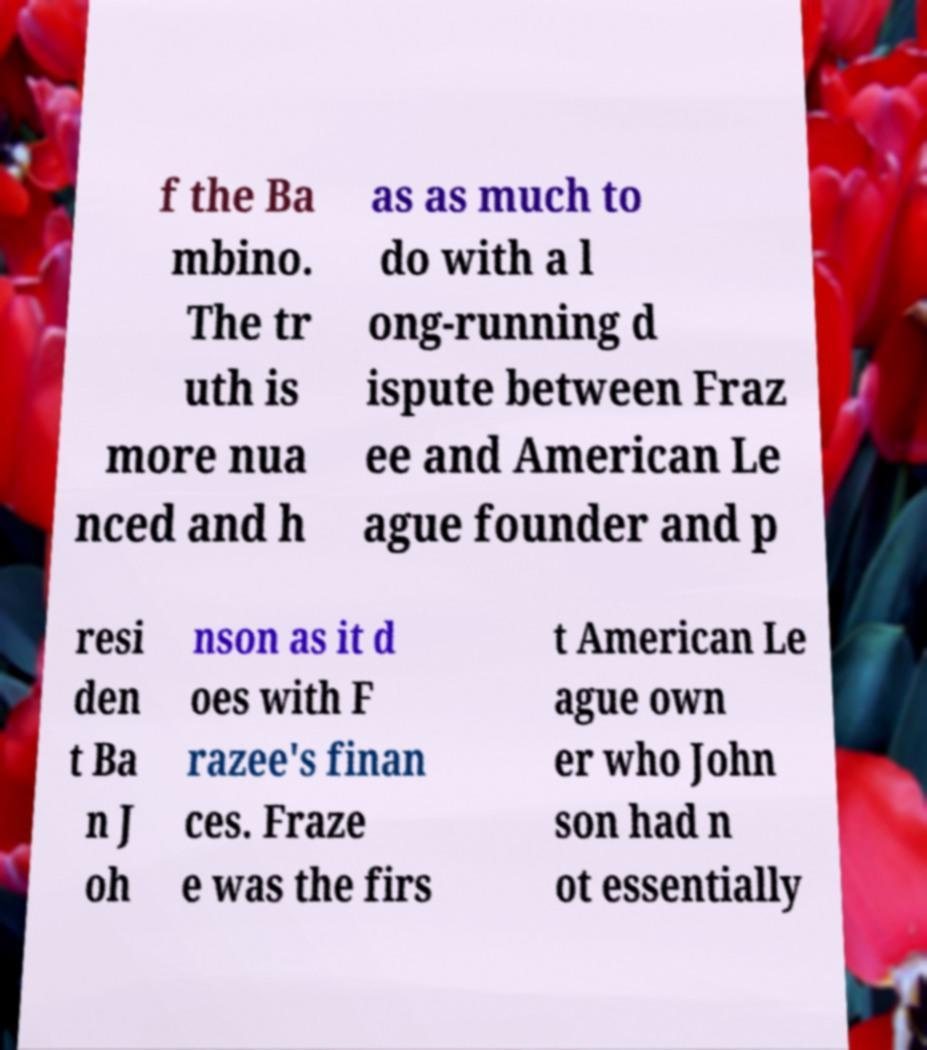Can you accurately transcribe the text from the provided image for me? f the Ba mbino. The tr uth is more nua nced and h as as much to do with a l ong-running d ispute between Fraz ee and American Le ague founder and p resi den t Ba n J oh nson as it d oes with F razee's finan ces. Fraze e was the firs t American Le ague own er who John son had n ot essentially 